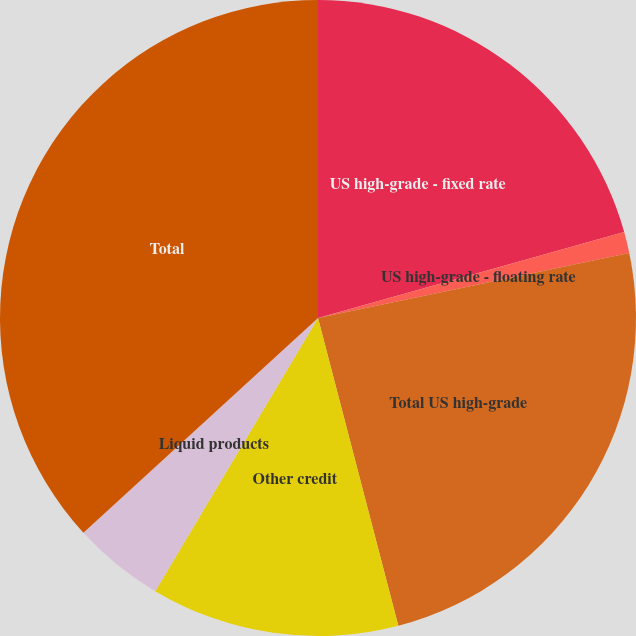Convert chart. <chart><loc_0><loc_0><loc_500><loc_500><pie_chart><fcel>US high-grade - fixed rate<fcel>US high-grade - floating rate<fcel>Total US high-grade<fcel>Other credit<fcel>Liquid products<fcel>Total<nl><fcel>20.65%<fcel>1.07%<fcel>24.22%<fcel>12.62%<fcel>4.65%<fcel>36.8%<nl></chart> 